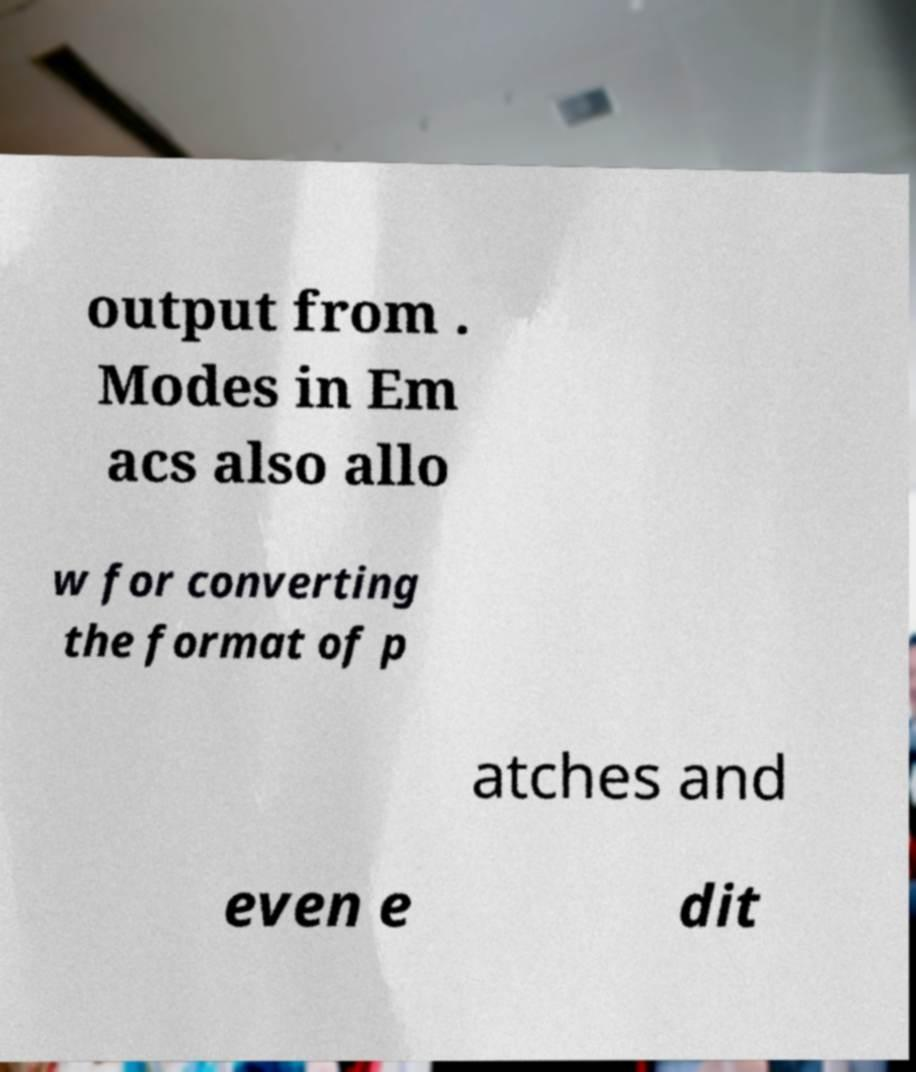Please read and relay the text visible in this image. What does it say? output from . Modes in Em acs also allo w for converting the format of p atches and even e dit 